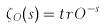Convert formula to latex. <formula><loc_0><loc_0><loc_500><loc_500>\zeta _ { O } ( s ) = t r O ^ { - s }</formula> 